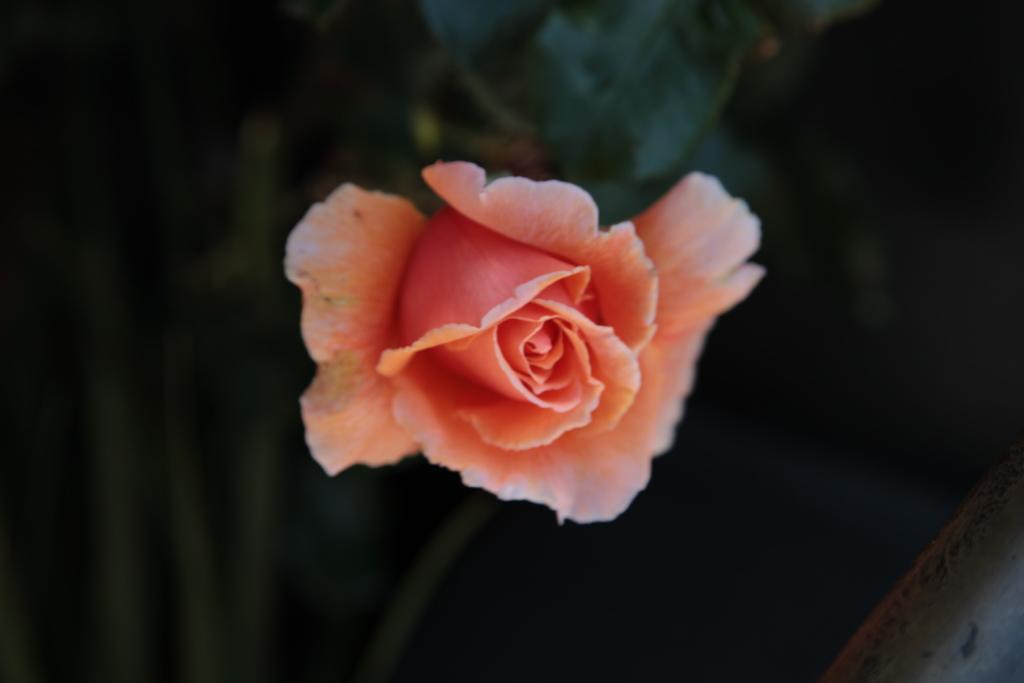What type of flower is in the image? There is a rose flower in the image. What suggestion does the rose flower give to the person in the image? The image does not depict a person, and the rose flower cannot give suggestions, as it is a plant and does not have the ability to communicate in that manner. 